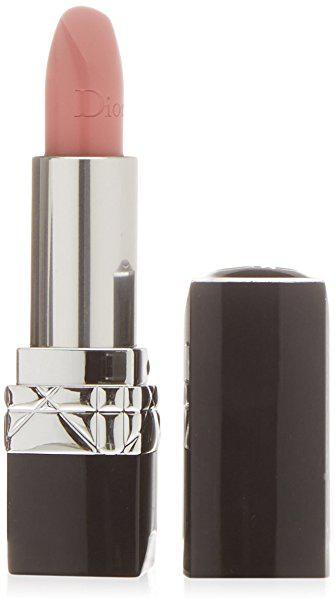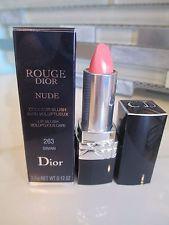The first image is the image on the left, the second image is the image on the right. Analyze the images presented: Is the assertion "One of the images shows a single lipstick on display and the other shows a group of at least three lipsticks." valid? Answer yes or no. No. 